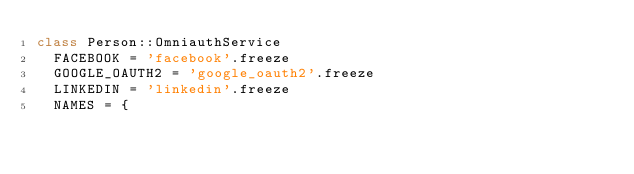<code> <loc_0><loc_0><loc_500><loc_500><_Ruby_>class Person::OmniauthService
  FACEBOOK = 'facebook'.freeze
  GOOGLE_OAUTH2 = 'google_oauth2'.freeze
  LINKEDIN = 'linkedin'.freeze
  NAMES = {</code> 